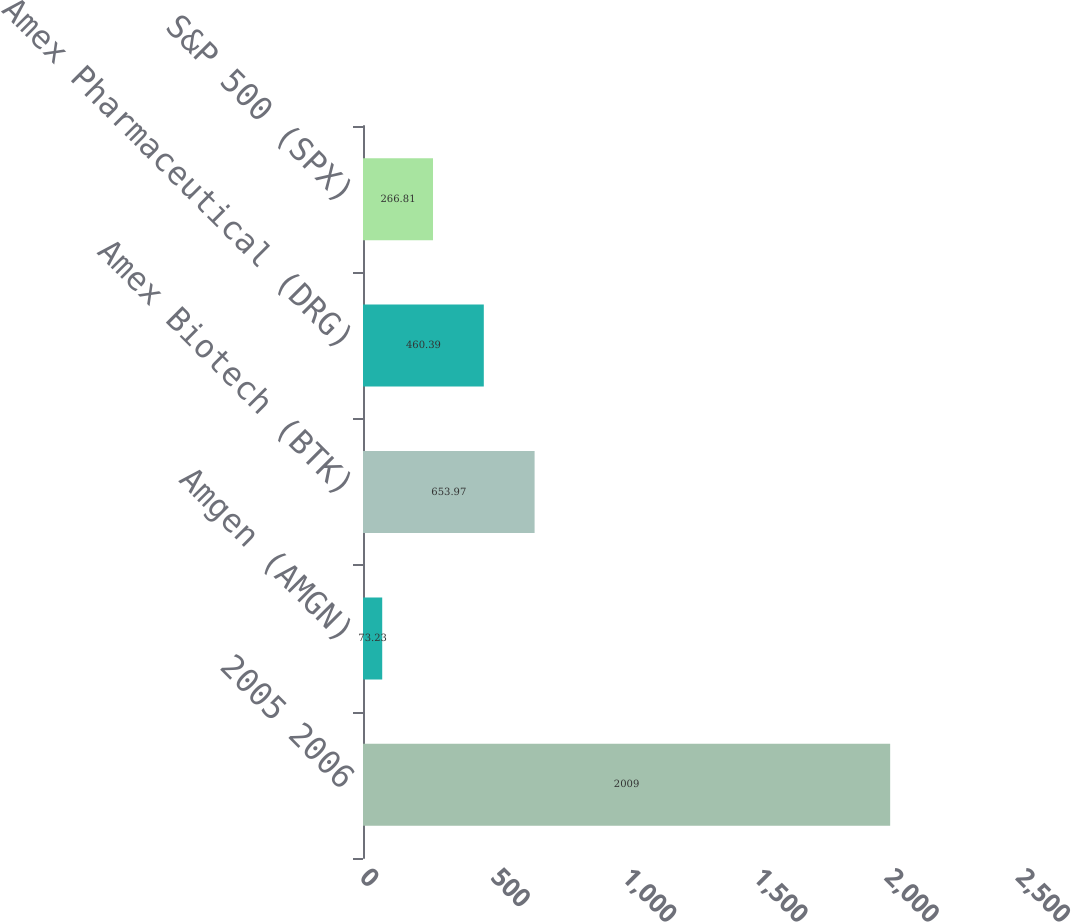<chart> <loc_0><loc_0><loc_500><loc_500><bar_chart><fcel>2005 2006<fcel>Amgen (AMGN)<fcel>Amex Biotech (BTK)<fcel>Amex Pharmaceutical (DRG)<fcel>S&P 500 (SPX)<nl><fcel>2009<fcel>73.23<fcel>653.97<fcel>460.39<fcel>266.81<nl></chart> 